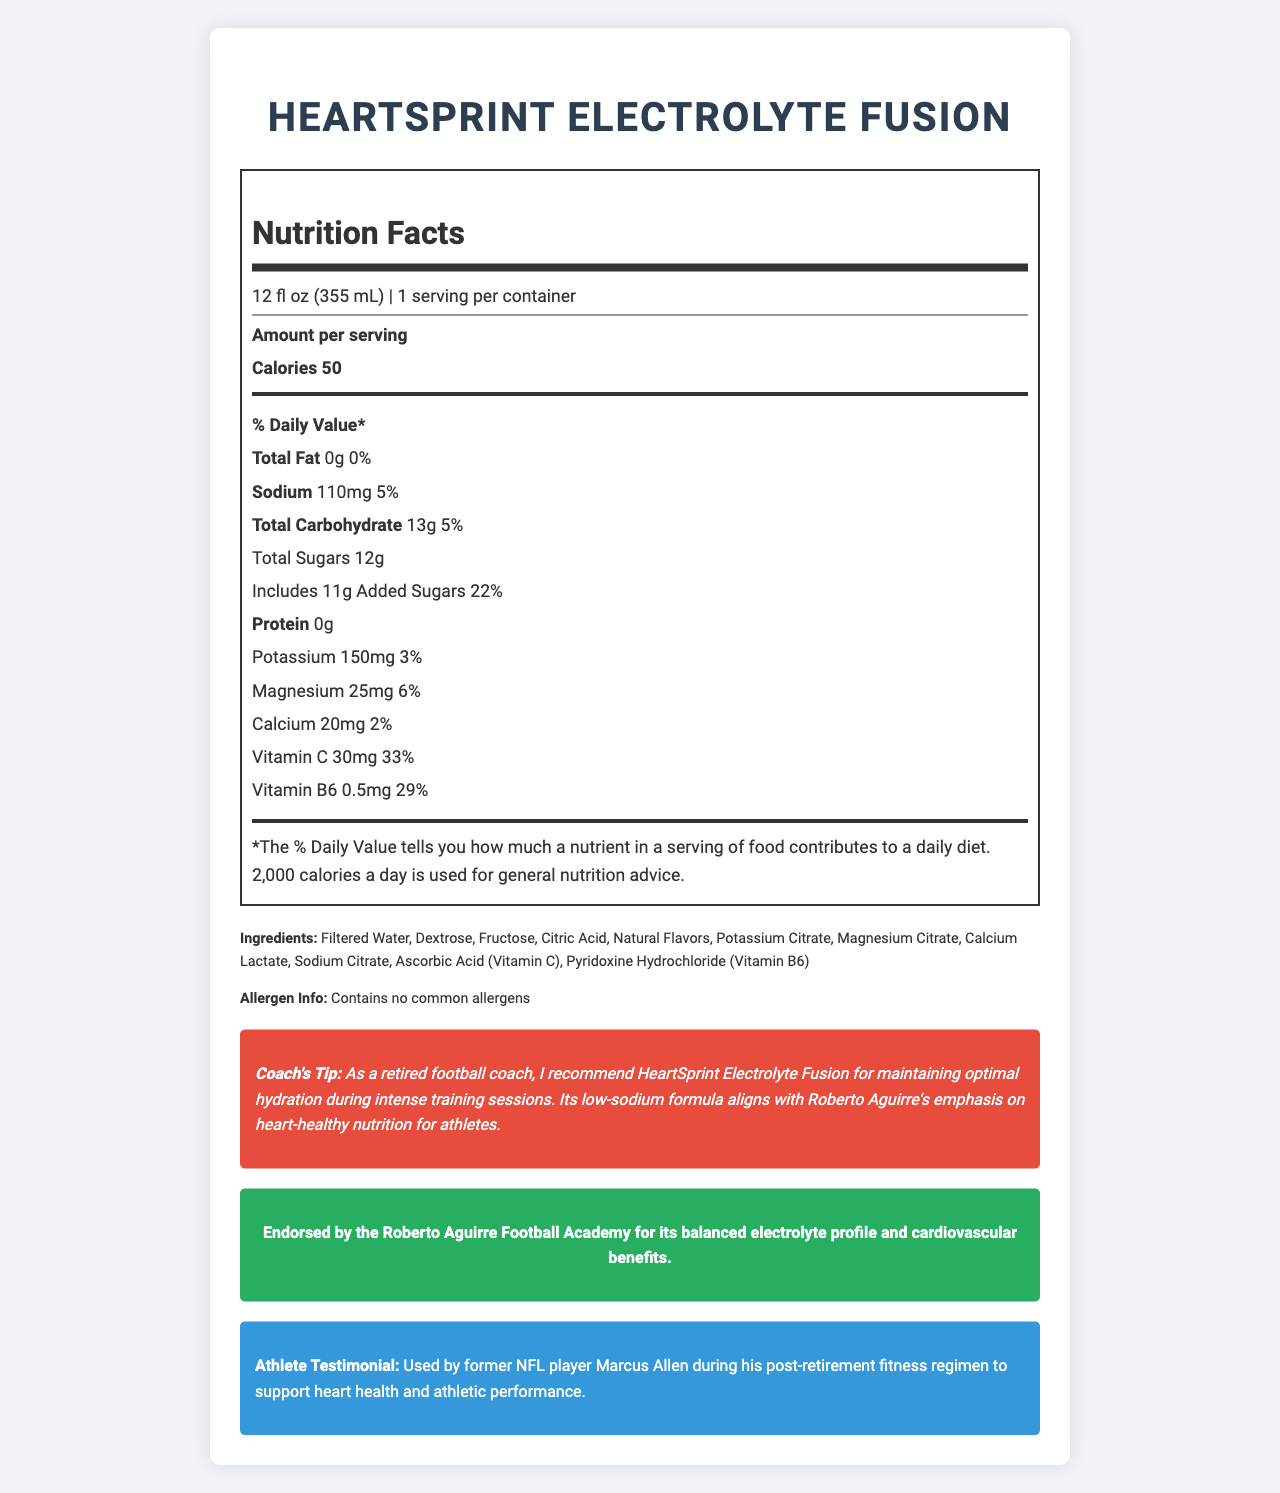what is the serving size of HeartSprint Electrolyte Fusion? The serving size is mentioned under the product's name and serving information.
Answer: 12 fl oz (355 mL) how many calories are there per serving? The number of calories per serving is listed in the "Amount per serving" section.
Answer: 50 how much sodium is in one serving? The amount of sodium is specified under the daily value percentages.
Answer: 110mg what is the percentage of daily value for added sugars? The daily value percentage for added sugars is listed in the total carbohydrate section.
Answer: 22% how many grams of total fat are in one serving? The total fat content is specified in the daily value section.
Answer: 0g which vitamin has the highest percentage of daily value in HeartSprint Electrolyte Fusion? A. Vitamin C B. Vitamin B6 C. Calcium D. Magnesium The daily value for Vitamin C is 33%, which is higher than Vitamin B6 (29%), Calcium (2%), and Magnesium (6%).
Answer: A what is the serving per container? A. 1 B. 2 C. 3 D. 4 The servings per container is 1, as mentioned under the serving size and servings per container.
Answer: A is this product suitable for individuals with common allergies? The allergen info states that it contains no common allergens.
Answer: Yes summarize the main idea of the document. The main idea includes the product's nutritional facts, key ingredients, and endorsements, highlighting its focus on heart health and electrolyte balance.
Answer: The document provides comprehensive nutritional information for HeartSprint Electrolyte Fusion, a low-sodium, heart-healthy sports drink endorsed for its balanced electrolyte profile. It includes serving size, calorie count, macronutrient breakdown, vitamins, and minerals, along with special endorsements and recommendations for athletes. who is the retired NFL player mentioned in the athlete testimonial? The document explicitly mentions Marcus Allen in the athlete testimonial section.
Answer: Marcus Allen list all the ingredients in HeartSprint Electrolyte Fusion. The ingredients are listed in the ingredients section under the nutrition label.
Answer: Filtered Water, Dextrose, Fructose, Citric Acid, Natural Flavors, Potassium Citrate, Magnesium Citrate, Calcium Lactate, Sodium Citrate, Ascorbic Acid (Vitamin C), Pyridoxine Hydrochloride (Vitamin B6) what flavor options are available for HeartSprint Electrolyte Fusion? The document does not specify any flavor options, only that it contains Natural Flavors.
Answer: Cannot be determined how much protein is in one serving? The protein content is listed as 0g in the daily value section.
Answer: 0g what is the total carbohydrate content in one serving? The total carbohydrate content is specified as 13g in the daily value section.
Answer: 13g is HeartSprint Electrolyte Fusion endorsed by any notable organizations? It is endorsed by the Roberto Aguirre Football Academy, as mentioned in the “Aguirre Approved” section.
Answer: Yes 